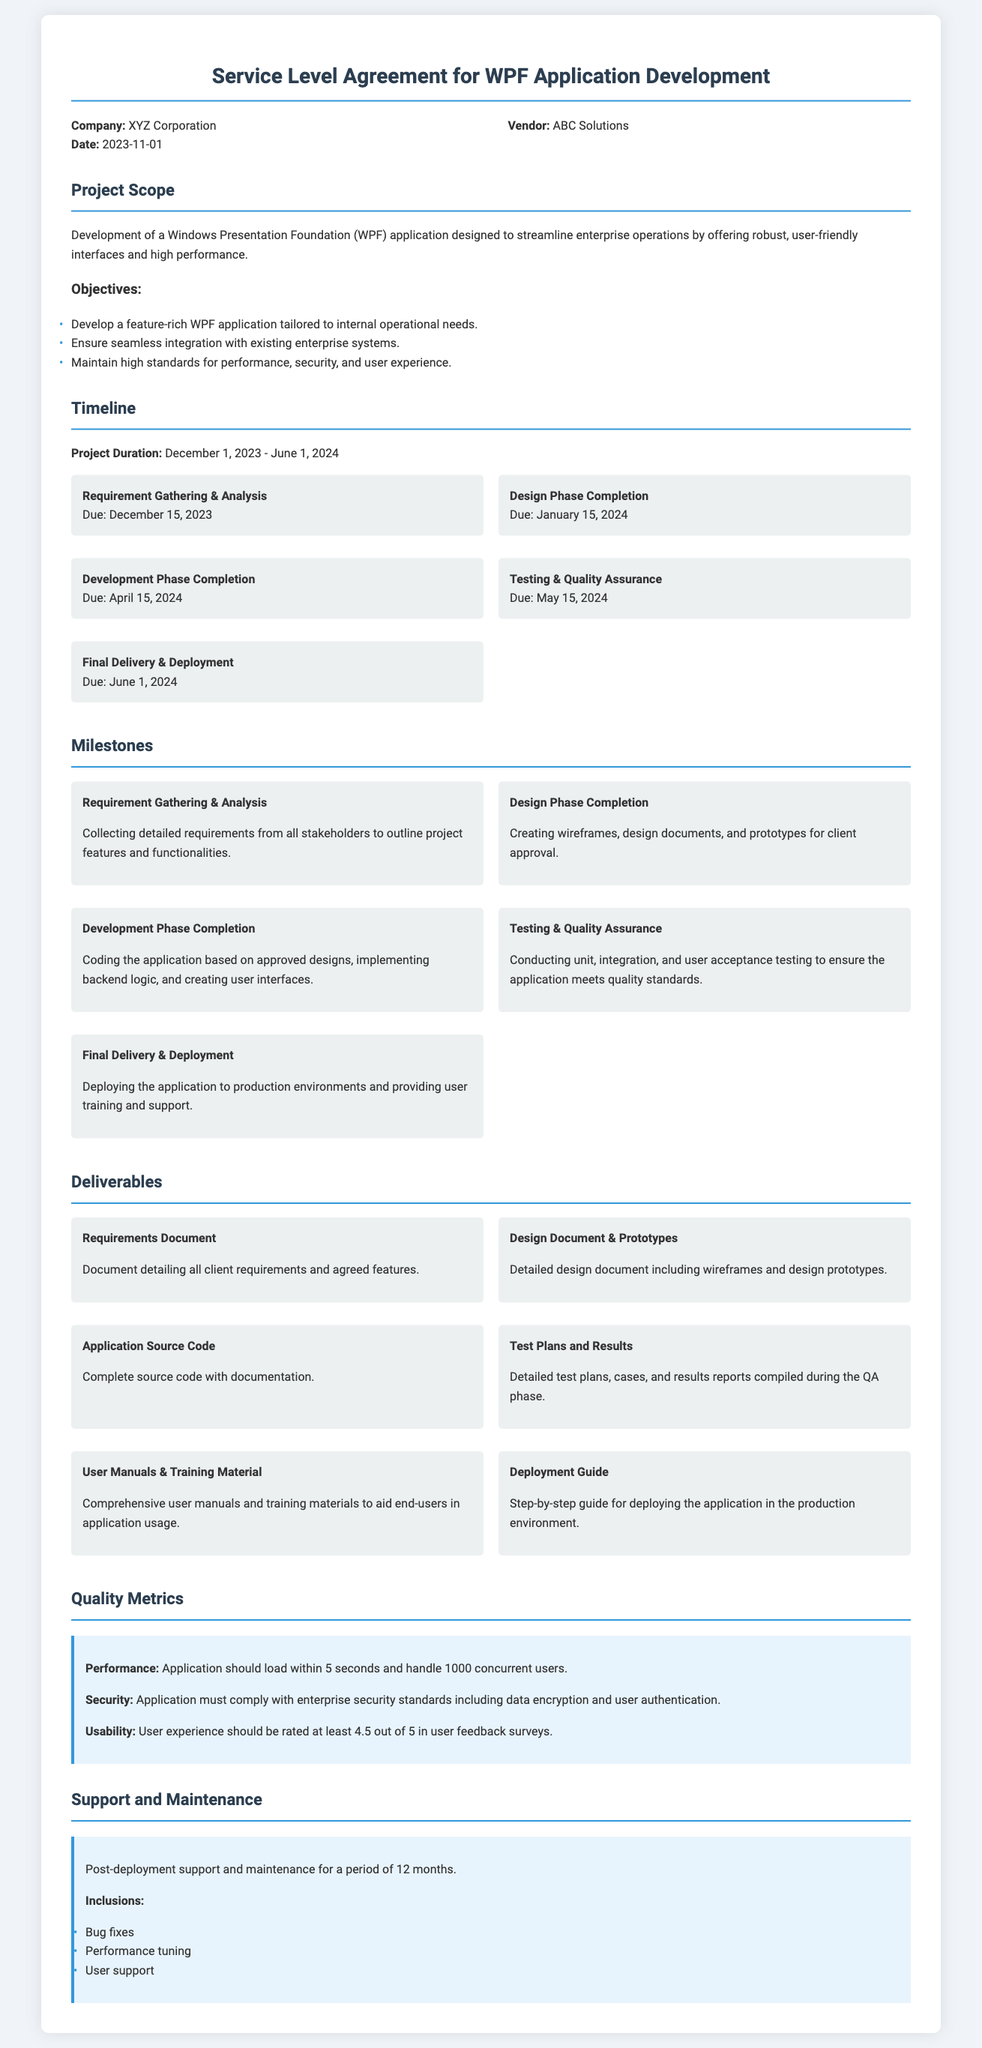What is the project duration? The project duration is explicitly stated in the timeline section of the document, which is from December 1, 2023, to June 1, 2024.
Answer: December 1, 2023 - June 1, 2024 Who is the vendor? The vendor is mentioned in the company information section of the document.
Answer: ABC Solutions What is the due date for testing & quality assurance? The due date for the testing & quality assurance phase is found in the timeline section.
Answer: May 15, 2024 What is included in the post-deployment support? The support and maintenance section lists what is included in the post-deployment support.
Answer: Bug fixes, Performance tuning, User support How many milestones are listed in the document? The number of milestones can be counted from the milestones section of the document.
Answer: Five What is the objective of the project? The objectives are summarized and listed in the project scope section of the document.
Answer: Develop a feature-rich WPF application tailored to internal operational needs What document provides detailed client requirements? The deliverables section specifies the documents provided upon completion of various phases.
Answer: Requirements Document What is the performance metric for the application? The quality metrics section lists the performance metric expected for the application.
Answer: Application should load within 5 seconds What is the completion date for the design phase? The completion date for the design phase is found in the timeline section.
Answer: January 15, 2024 